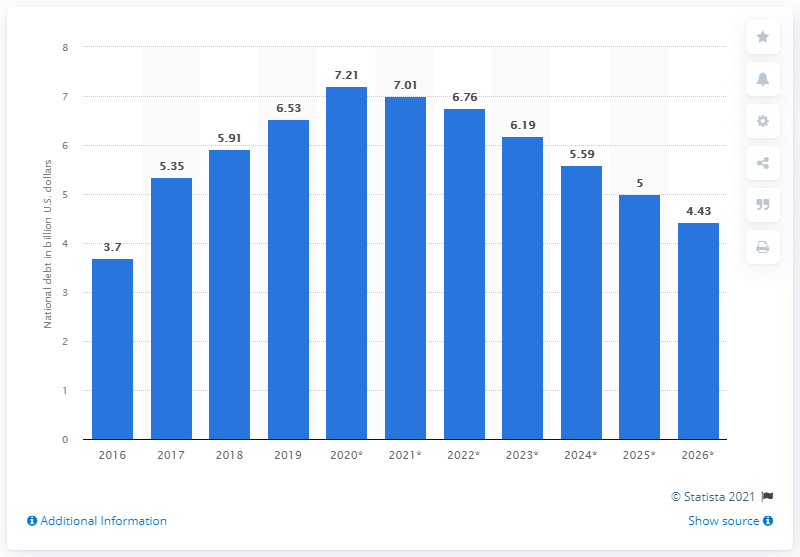Draw attention to some important aspects in this diagram. The national debt of the Democratic Republic of the Congo in 2019 was 6.53. 